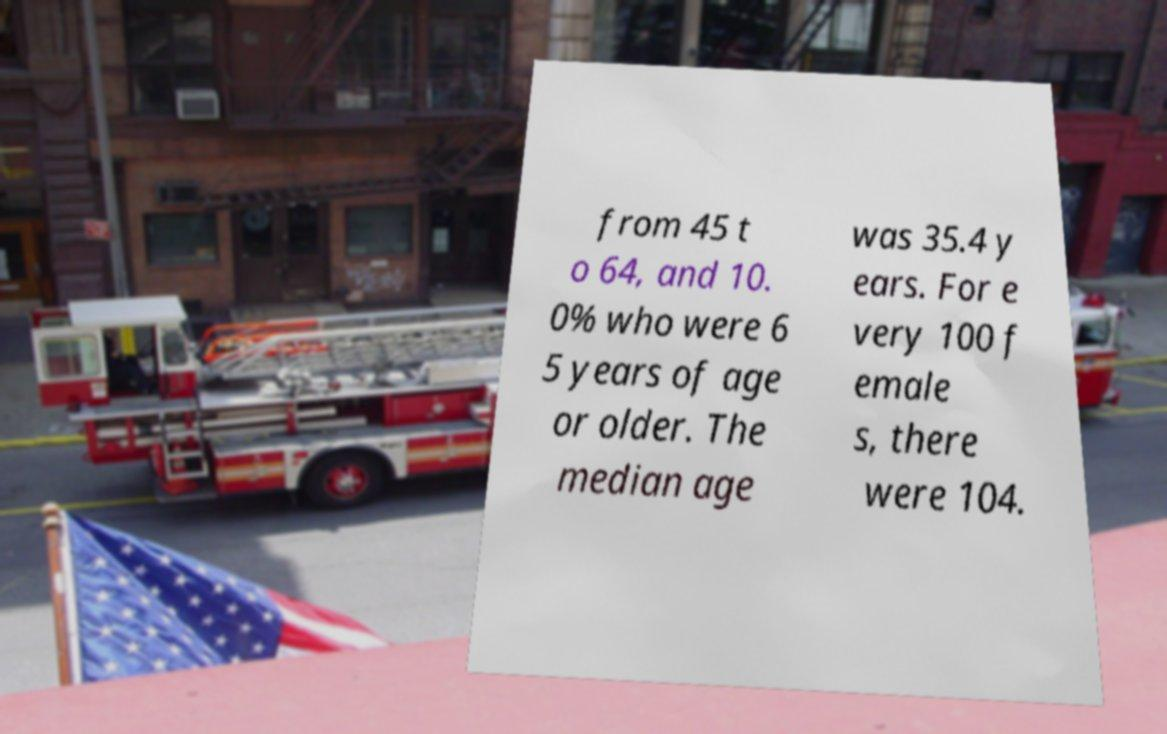Could you assist in decoding the text presented in this image and type it out clearly? from 45 t o 64, and 10. 0% who were 6 5 years of age or older. The median age was 35.4 y ears. For e very 100 f emale s, there were 104. 